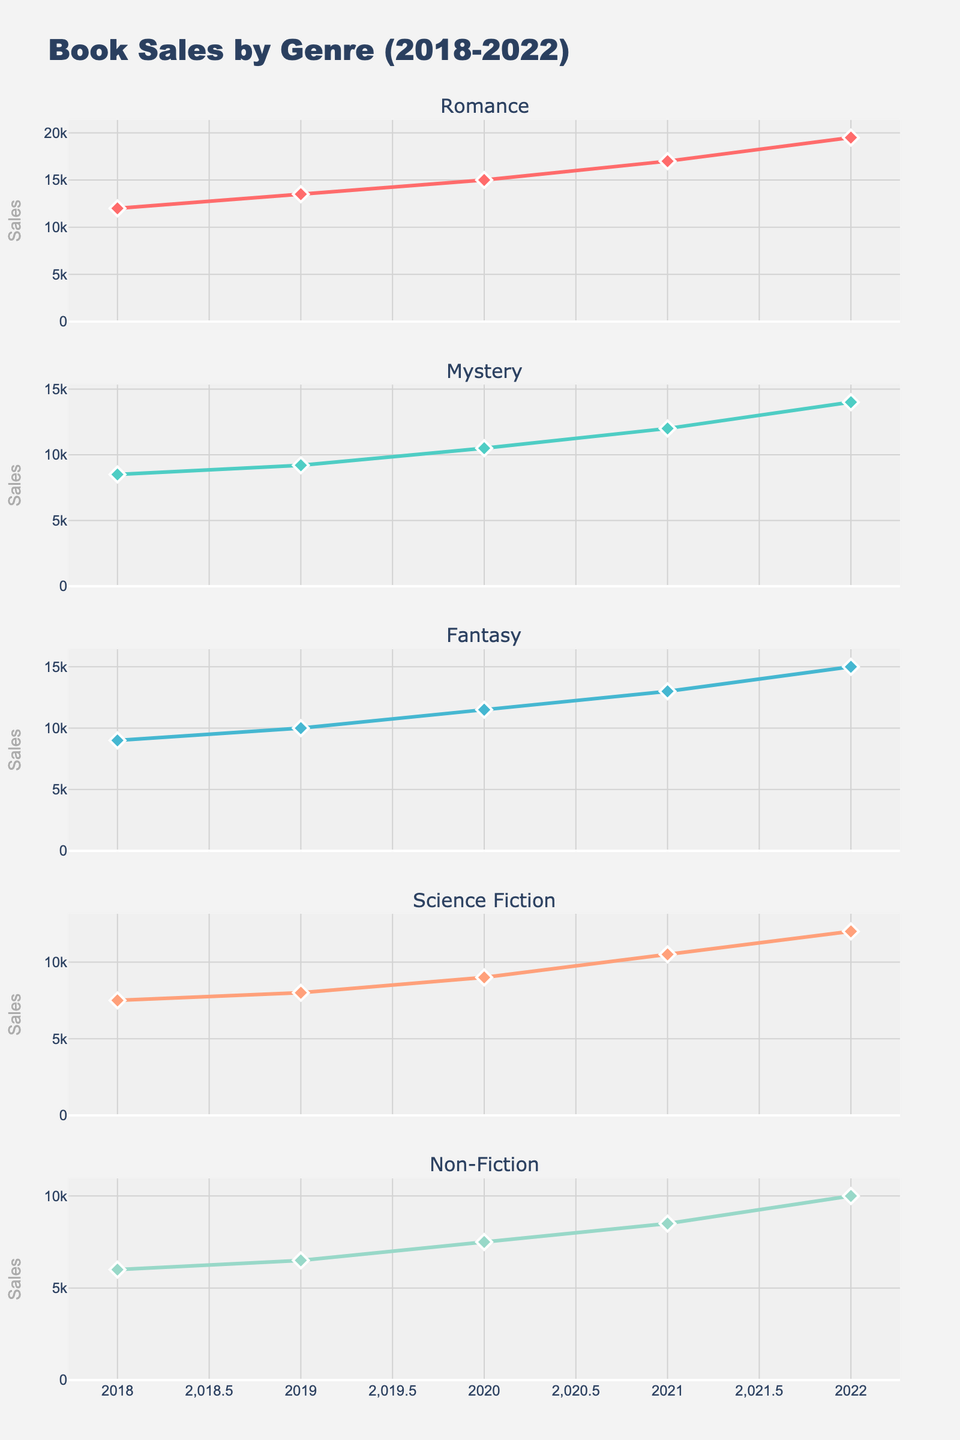What is the title of the plot? The title is located at the top of the figure and gives an overview of what the data represents.
Answer: Book Sales by Genre (2018-2022) How many subplots are there in the figure? Count the number of individual vertical sections in the figure.
Answer: 5 What genre had the highest book sales in 2022? Choose the subplot for 2022 and compare the heights of the lines.
Answer: Romance Which genre had the smallest sales increase from 2018 to 2022? Calculate the difference between sales in 2022 and 2018 for all genres, then check which one is the smallest. Non-Fiction: 10000 - 6000 = 4000, Science Fiction: 12000 - 7500 = 4500, Romance: 19500 - 12000 = 7500, Mystery: 14000 - 8500 = 5500, Fantasy: 15000 - 9000 = 6000
Answer: Non-Fiction What is the average book sales for Mystery across the given years? Sum the book sales for Mystery from 2018 to 2022 and divide by the number of years. (8500 + 9200 + 10500 + 12000 + 14000) / 5
Answer: 10840 In which year did Fantasy book sales surpass 10000? Look for the year where the line in the Fantasy subplot crosses the 10000-mark.
Answer: 2019 How did Science Fiction book sales trend from 2020 to 2021? Observe the direction of the line segment between 2020 and 2021 in the Science Fiction subplot.
Answer: Increased Which genre had the most consistent sales growth over the years? Compare the trends of all genres and see which one has the most uniform slope.
Answer: Romance Did Non-Fiction book sales exceed 8000 in 2021? Check the value of Non-Fiction in the 2021 subplot.
Answer: Yes 